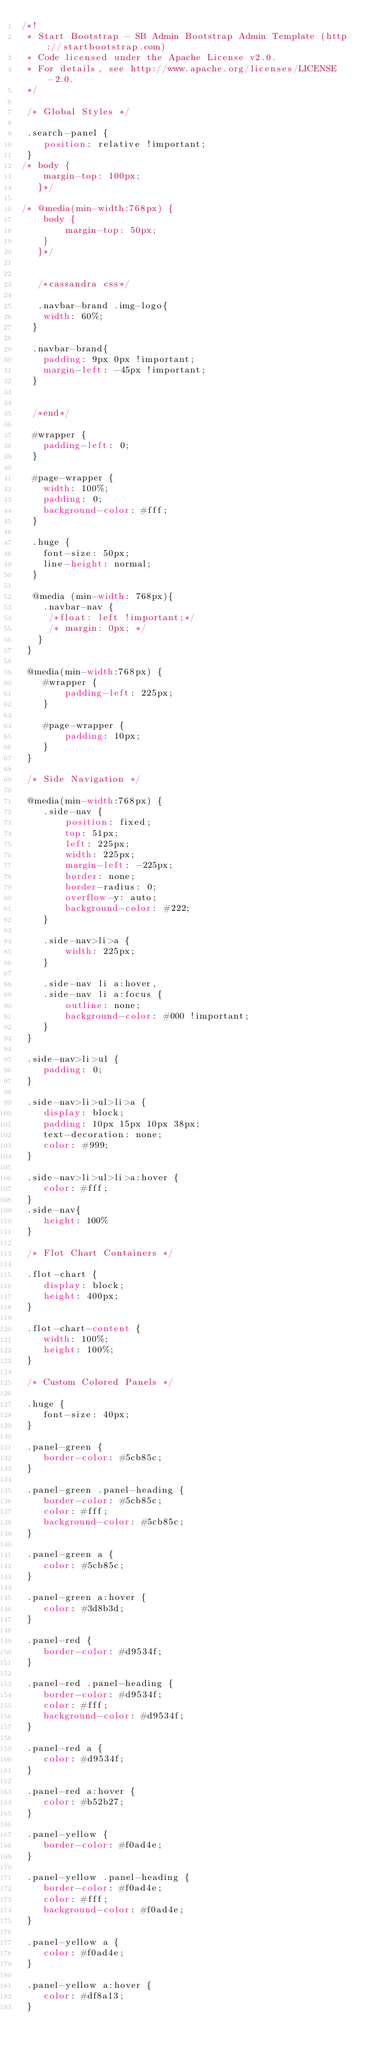<code> <loc_0><loc_0><loc_500><loc_500><_CSS_>/*!
 * Start Bootstrap - SB Admin Bootstrap Admin Template (http://startbootstrap.com)
 * Code licensed under the Apache License v2.0.
 * For details, see http://www.apache.org/licenses/LICENSE-2.0.
 */

 /* Global Styles */

 .search-panel {
 	position: relative !important;
 }
/* body {
 	margin-top: 100px;
   }*/

/* @media(min-width:768px) {
 	body {
 		margin-top: 50px;
 	}
   }*/


   /*cassandra css*/

   .navbar-brand .img-logo{
    width: 60%;
  }

  .navbar-brand{
    padding: 9px 0px !important;
    margin-left: -45px !important;
  }


  /*end*/

  #wrapper {
    padding-left: 0;
  }

  #page-wrapper {
    width: 100%;
    padding: 0;
    background-color: #fff;
  }

  .huge {
    font-size: 50px;
    line-height: normal;
  }

  @media (min-width: 768px){
    .navbar-nav {
     /*float: left !important;*/
     /* margin: 0px; */
   }
 }

 @media(min-width:768px) {
 	#wrapper {
 		padding-left: 225px;
 	}

 	#page-wrapper {
 		padding: 10px;
 	}
 }

 /* Side Navigation */

 @media(min-width:768px) {
 	.side-nav {
 		position: fixed;
 		top: 51px;
 		left: 225px;
 		width: 225px;
 		margin-left: -225px;
 		border: none;
 		border-radius: 0;
 		overflow-y: auto;
 		background-color: #222;
 	}

 	.side-nav>li>a {
 		width: 225px;
 	}

 	.side-nav li a:hover,
 	.side-nav li a:focus {
 		outline: none;
 		background-color: #000 !important;
 	}
 }

 .side-nav>li>ul {
 	padding: 0;
 }

 .side-nav>li>ul>li>a {
 	display: block;
 	padding: 10px 15px 10px 38px;
 	text-decoration: none;
 	color: #999;
 }

 .side-nav>li>ul>li>a:hover {
 	color: #fff;
 }
 .side-nav{
 	height: 100%
 }

 /* Flot Chart Containers */

 .flot-chart {
 	display: block;
 	height: 400px;
 }

 .flot-chart-content {
 	width: 100%;
 	height: 100%;
 }

 /* Custom Colored Panels */

 .huge {
 	font-size: 40px;
 }

 .panel-green {
 	border-color: #5cb85c;
 }

 .panel-green .panel-heading {
 	border-color: #5cb85c;
 	color: #fff;
 	background-color: #5cb85c;
 }

 .panel-green a {
 	color: #5cb85c;
 }

 .panel-green a:hover {
 	color: #3d8b3d;
 }

 .panel-red {
 	border-color: #d9534f;
 }

 .panel-red .panel-heading {
 	border-color: #d9534f;
 	color: #fff;
 	background-color: #d9534f;
 }

 .panel-red a {
 	color: #d9534f;
 }

 .panel-red a:hover {
 	color: #b52b27;
 }

 .panel-yellow {
 	border-color: #f0ad4e;
 }

 .panel-yellow .panel-heading {
 	border-color: #f0ad4e;
 	color: #fff;
 	background-color: #f0ad4e;
 }

 .panel-yellow a {
 	color: #f0ad4e;
 }

 .panel-yellow a:hover {
 	color: #df8a13;
 }
</code> 